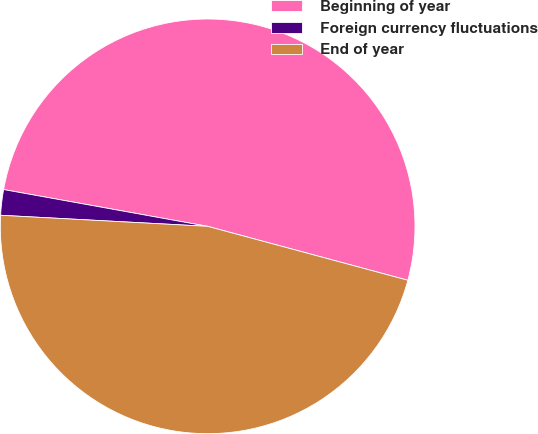Convert chart. <chart><loc_0><loc_0><loc_500><loc_500><pie_chart><fcel>Beginning of year<fcel>Foreign currency fluctuations<fcel>End of year<nl><fcel>51.35%<fcel>1.99%<fcel>46.66%<nl></chart> 